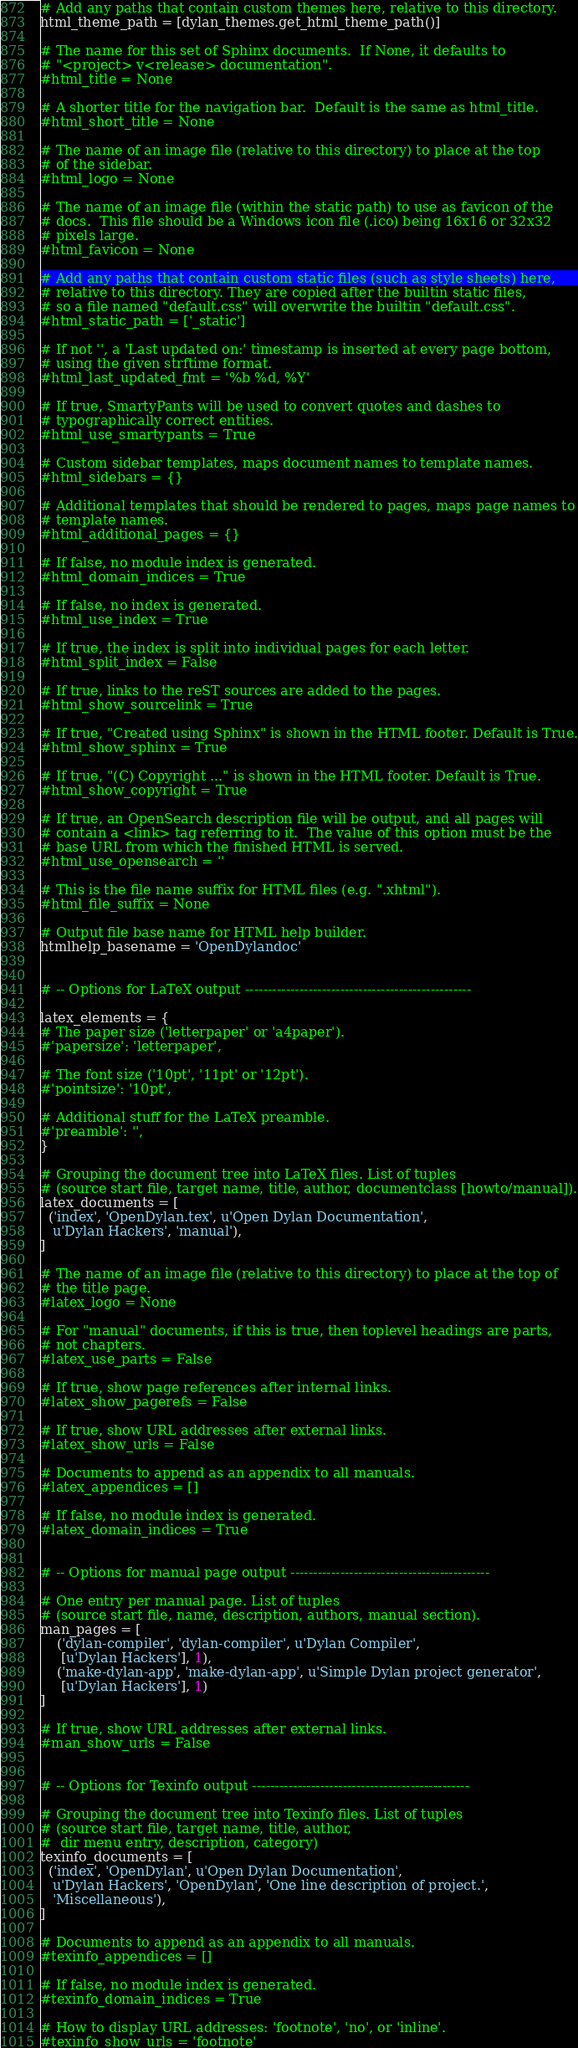Convert code to text. <code><loc_0><loc_0><loc_500><loc_500><_Python_># Add any paths that contain custom themes here, relative to this directory.
html_theme_path = [dylan_themes.get_html_theme_path()]

# The name for this set of Sphinx documents.  If None, it defaults to
# "<project> v<release> documentation".
#html_title = None

# A shorter title for the navigation bar.  Default is the same as html_title.
#html_short_title = None

# The name of an image file (relative to this directory) to place at the top
# of the sidebar.
#html_logo = None

# The name of an image file (within the static path) to use as favicon of the
# docs.  This file should be a Windows icon file (.ico) being 16x16 or 32x32
# pixels large.
#html_favicon = None

# Add any paths that contain custom static files (such as style sheets) here,
# relative to this directory. They are copied after the builtin static files,
# so a file named "default.css" will overwrite the builtin "default.css".
#html_static_path = ['_static']

# If not '', a 'Last updated on:' timestamp is inserted at every page bottom,
# using the given strftime format.
#html_last_updated_fmt = '%b %d, %Y'

# If true, SmartyPants will be used to convert quotes and dashes to
# typographically correct entities.
#html_use_smartypants = True

# Custom sidebar templates, maps document names to template names.
#html_sidebars = {}

# Additional templates that should be rendered to pages, maps page names to
# template names.
#html_additional_pages = {}

# If false, no module index is generated.
#html_domain_indices = True

# If false, no index is generated.
#html_use_index = True

# If true, the index is split into individual pages for each letter.
#html_split_index = False

# If true, links to the reST sources are added to the pages.
#html_show_sourcelink = True

# If true, "Created using Sphinx" is shown in the HTML footer. Default is True.
#html_show_sphinx = True

# If true, "(C) Copyright ..." is shown in the HTML footer. Default is True.
#html_show_copyright = True

# If true, an OpenSearch description file will be output, and all pages will
# contain a <link> tag referring to it.  The value of this option must be the
# base URL from which the finished HTML is served.
#html_use_opensearch = ''

# This is the file name suffix for HTML files (e.g. ".xhtml").
#html_file_suffix = None

# Output file base name for HTML help builder.
htmlhelp_basename = 'OpenDylandoc'


# -- Options for LaTeX output --------------------------------------------------

latex_elements = {
# The paper size ('letterpaper' or 'a4paper').
#'papersize': 'letterpaper',

# The font size ('10pt', '11pt' or '12pt').
#'pointsize': '10pt',

# Additional stuff for the LaTeX preamble.
#'preamble': '',
}

# Grouping the document tree into LaTeX files. List of tuples
# (source start file, target name, title, author, documentclass [howto/manual]).
latex_documents = [
  ('index', 'OpenDylan.tex', u'Open Dylan Documentation',
   u'Dylan Hackers', 'manual'),
]

# The name of an image file (relative to this directory) to place at the top of
# the title page.
#latex_logo = None

# For "manual" documents, if this is true, then toplevel headings are parts,
# not chapters.
#latex_use_parts = False

# If true, show page references after internal links.
#latex_show_pagerefs = False

# If true, show URL addresses after external links.
#latex_show_urls = False

# Documents to append as an appendix to all manuals.
#latex_appendices = []

# If false, no module index is generated.
#latex_domain_indices = True


# -- Options for manual page output --------------------------------------------

# One entry per manual page. List of tuples
# (source start file, name, description, authors, manual section).
man_pages = [
    ('dylan-compiler', 'dylan-compiler', u'Dylan Compiler',
     [u'Dylan Hackers'], 1),
    ('make-dylan-app', 'make-dylan-app', u'Simple Dylan project generator',
     [u'Dylan Hackers'], 1)
]

# If true, show URL addresses after external links.
#man_show_urls = False


# -- Options for Texinfo output ------------------------------------------------

# Grouping the document tree into Texinfo files. List of tuples
# (source start file, target name, title, author,
#  dir menu entry, description, category)
texinfo_documents = [
  ('index', 'OpenDylan', u'Open Dylan Documentation',
   u'Dylan Hackers', 'OpenDylan', 'One line description of project.',
   'Miscellaneous'),
]

# Documents to append as an appendix to all manuals.
#texinfo_appendices = []

# If false, no module index is generated.
#texinfo_domain_indices = True

# How to display URL addresses: 'footnote', 'no', or 'inline'.
#texinfo_show_urls = 'footnote'
</code> 